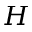<formula> <loc_0><loc_0><loc_500><loc_500>H</formula> 